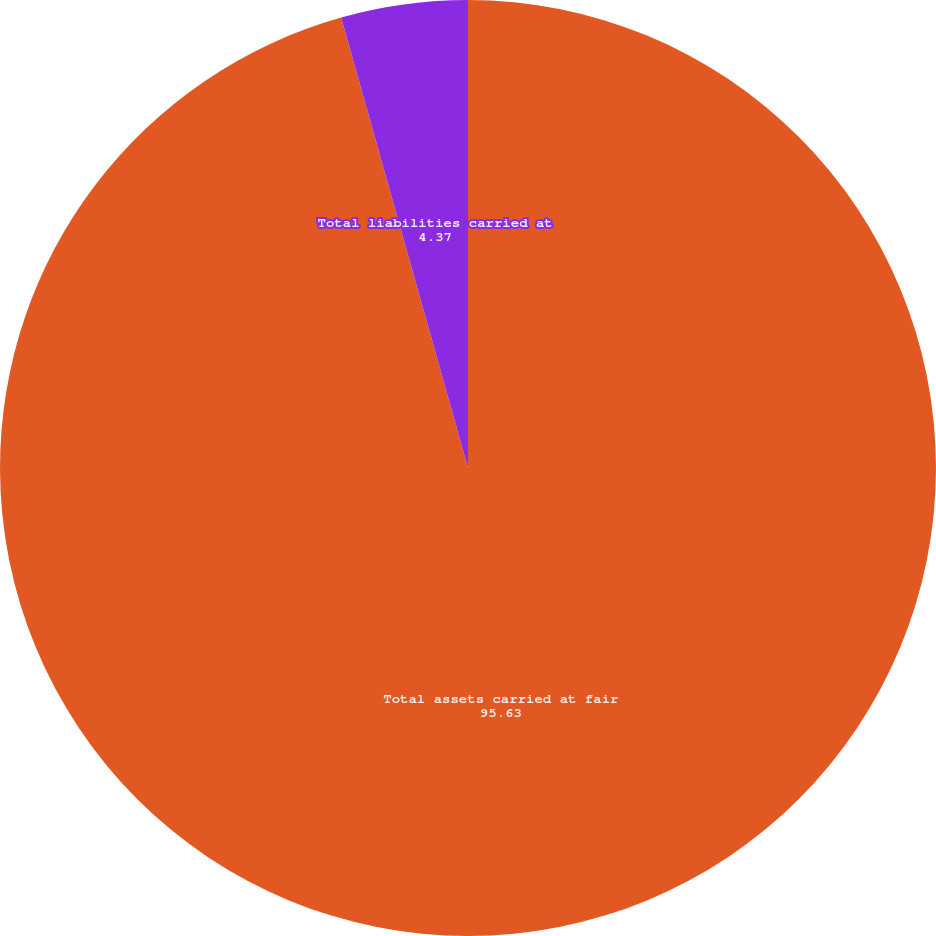<chart> <loc_0><loc_0><loc_500><loc_500><pie_chart><fcel>Total assets carried at fair<fcel>Total liabilities carried at<nl><fcel>95.63%<fcel>4.37%<nl></chart> 